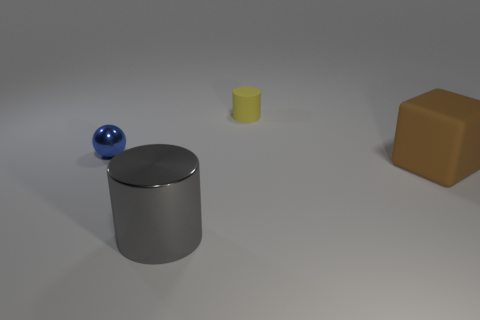Can you estimate the positioning of these objects in relation to each other? The blue sphere is positioned in the foreground on the left side, the matte cylinder is located centrally in the mid-ground, and the brown cube is situated to the right, slightly further away from the viewer than the cylinder. 